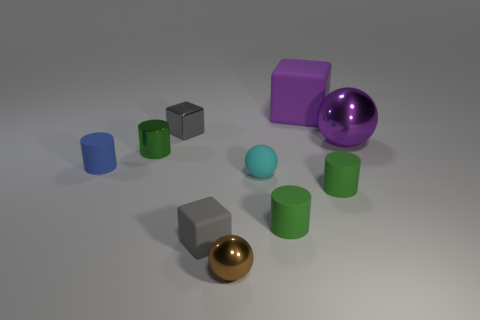Subtract all green spheres. How many green cylinders are left? 3 Subtract all balls. How many objects are left? 7 Subtract all tiny red metallic things. Subtract all purple shiny things. How many objects are left? 9 Add 8 tiny cyan things. How many tiny cyan things are left? 9 Add 2 blue shiny cylinders. How many blue shiny cylinders exist? 2 Subtract 0 red cylinders. How many objects are left? 10 